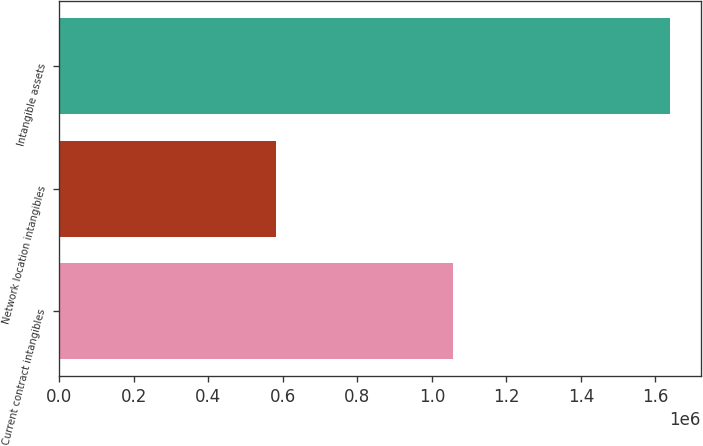Convert chart. <chart><loc_0><loc_0><loc_500><loc_500><bar_chart><fcel>Current contract intangibles<fcel>Network location intangibles<fcel>Intangible assets<nl><fcel>1.05748e+06<fcel>582305<fcel>1.63978e+06<nl></chart> 